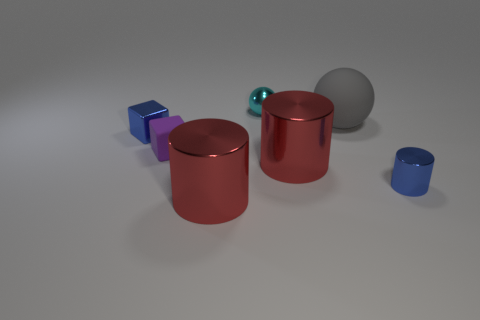Add 3 tiny gray metallic objects. How many objects exist? 10 Subtract all tiny cylinders. How many cylinders are left? 2 Subtract all cyan balls. How many balls are left? 1 Subtract 1 cubes. How many cubes are left? 1 Subtract 0 green spheres. How many objects are left? 7 Subtract all cylinders. How many objects are left? 4 Subtract all blue blocks. Subtract all purple cylinders. How many blocks are left? 1 Subtract all gray spheres. How many gray cylinders are left? 0 Subtract all cylinders. Subtract all small blue metallic cylinders. How many objects are left? 3 Add 1 cyan balls. How many cyan balls are left? 2 